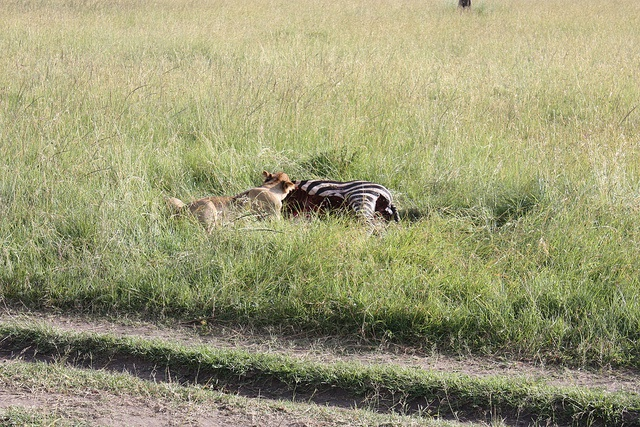Describe the objects in this image and their specific colors. I can see zebra in tan, black, gray, and darkgray tones and cat in tan and gray tones in this image. 